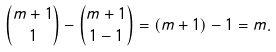<formula> <loc_0><loc_0><loc_500><loc_500>\binom { m + 1 } { 1 } - \binom { m + 1 } { 1 - 1 } = \left ( m + 1 \right ) - 1 = m .</formula> 